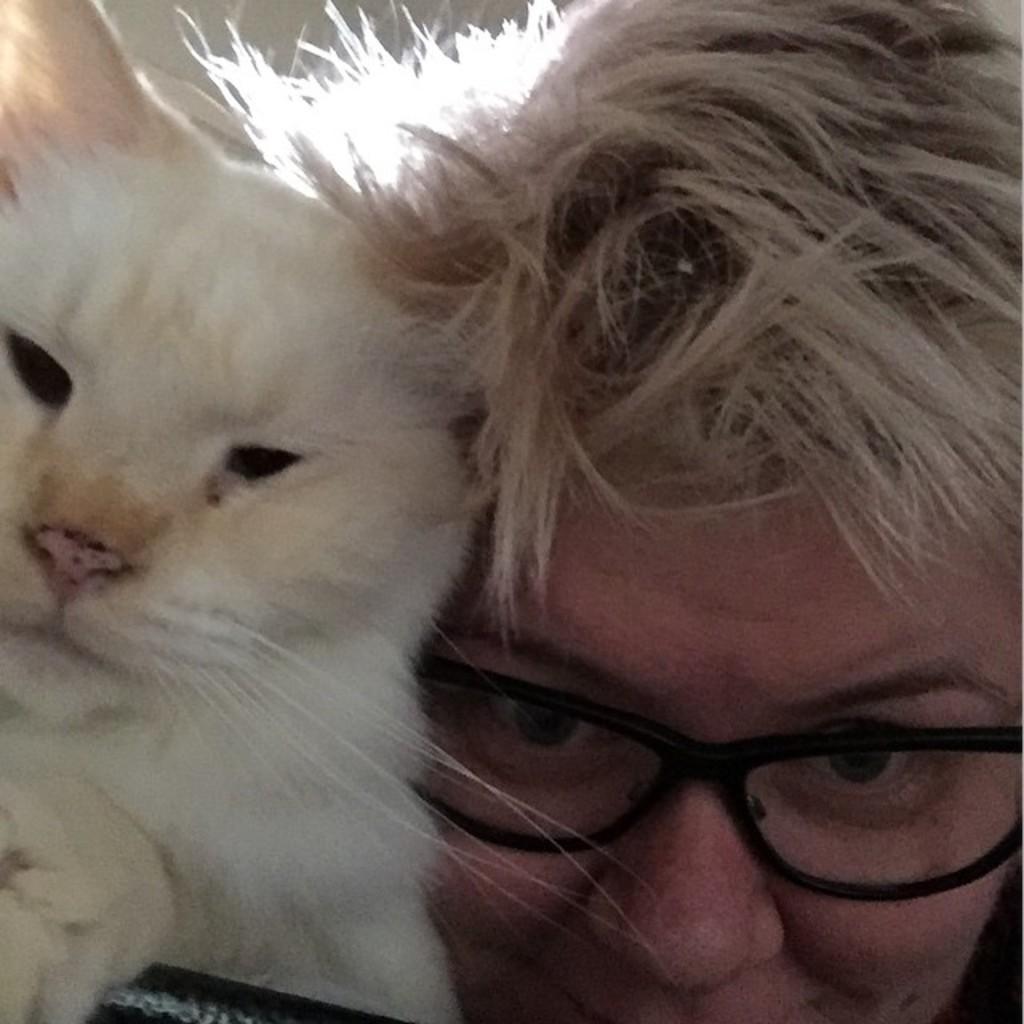How would you summarize this image in a sentence or two? This is the picture of a person who has white hair and spectacles and a dog which is in white color. 